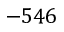<formula> <loc_0><loc_0><loc_500><loc_500>- 5 4 6</formula> 